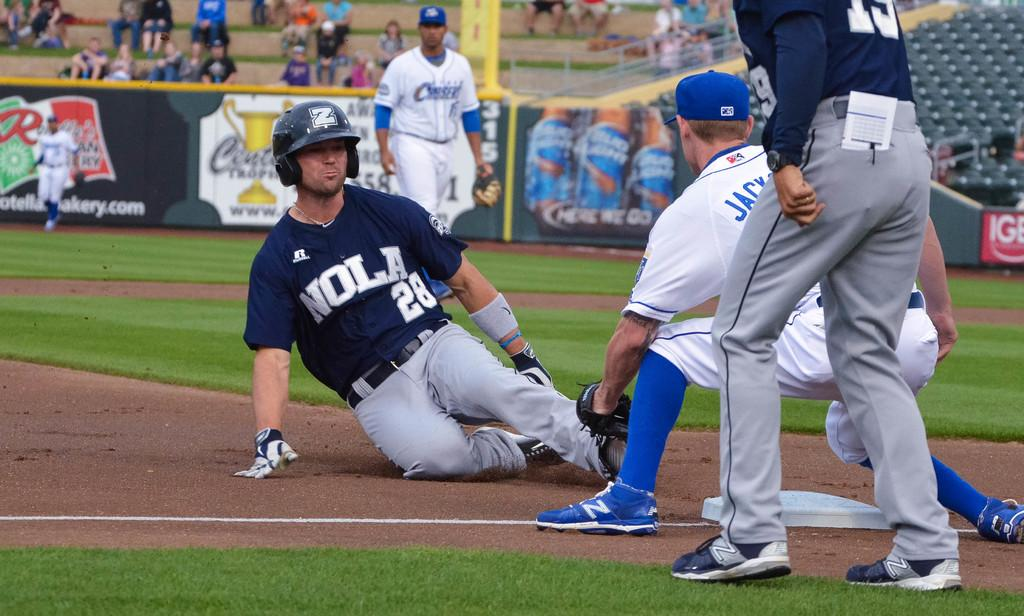<image>
Summarize the visual content of the image. A baseball player wearing a NOLA jersey slides into a base while a different player tries to tag him out. 